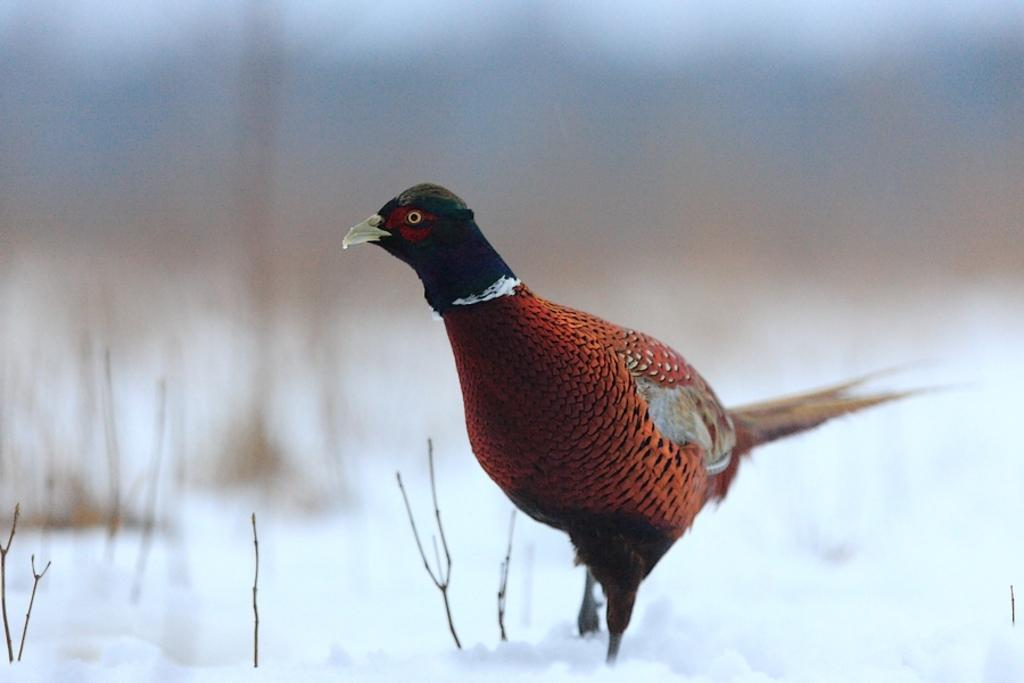What type of animal is in the image? There is a bird in the image. What colors can be seen on the bird? The bird has orange, ash, black, white, and red colors. What is the bird standing on? The bird is standing on snow. How would you describe the background of the image? The background of the image is blurry. What route does the government plan to take to address the issue of climate change? The image does not contain any information about government plans or climate change; it features a bird standing on snow. 